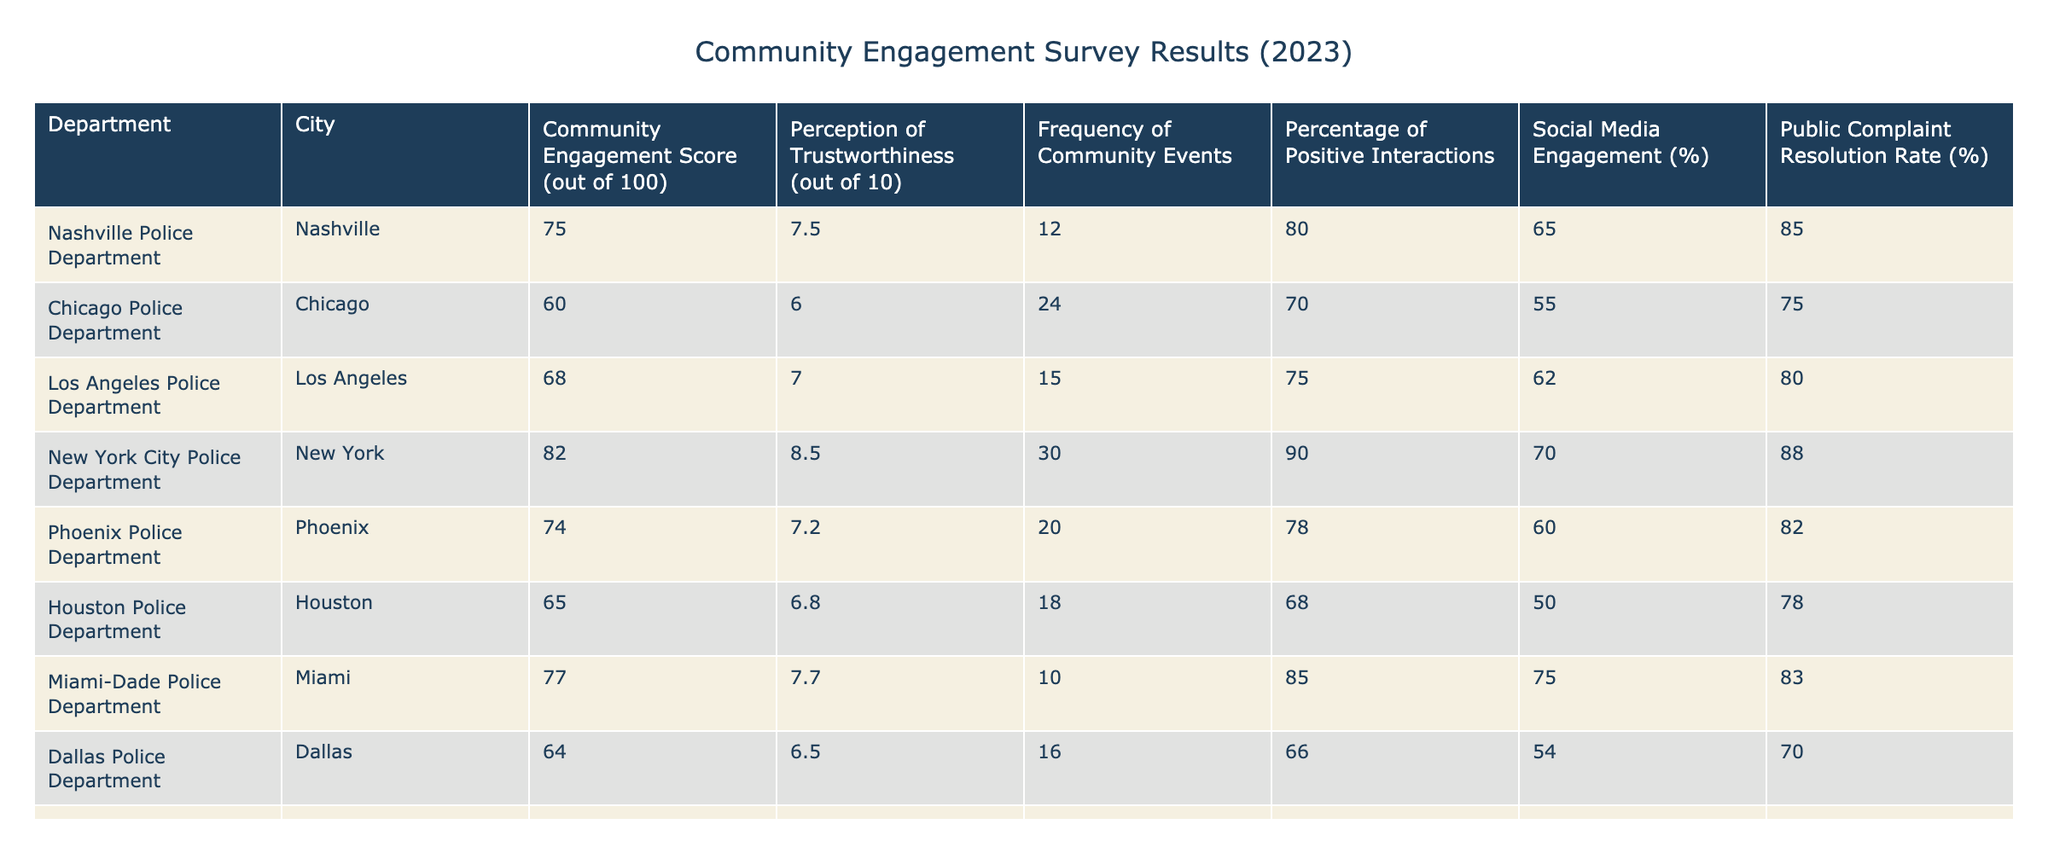What is the Community Engagement Score of the New York City Police Department? The Community Engagement Score can be found in the corresponding row for the New York City Police Department. This department's score is listed as 82.
Answer: 82 Which department has the highest Perception of Trustworthiness? By examining the Perception of Trustworthiness column, we see that the New York City Police Department has a score of 8.5, which is the highest compared to other departments.
Answer: New York City Police Department What is the percentage of positive interactions for the Chicago Police Department? In the row for the Chicago Police Department, the Percentage of Positive Interactions is listed as 70%.
Answer: 70% Calculate the average Community Engagement Score of all departments listed. To find the average, add all the Community Engagement Scores together: 75 + 60 + 68 + 82 + 74 + 65 + 77 + 64 + 80 + 70 = 744. There are 10 departments, so 744 divided by 10 equals 74.4.
Answer: 74.4 Is the Public Complaint Resolution Rate for the Miami-Dade Police Department above 80%? Look at the Public Complaint Resolution Rate for the Miami-Dade Police Department, which is listed as 83%. Since 83% is greater than 80%, the answer is yes.
Answer: Yes Which department has the lowest Social Media Engagement percentage? By checking the Social Media Engagement column, I see the lowest percentage is for the Houston Police Department, which is 50%.
Answer: Houston Police Department How many community events does the Seattle Police Department hold? In the cells for the Seattle Police Department, it lists that they conduct 22 community events.
Answer: 22 What is the difference in Community Engagement Scores between the Nashville Police Department and the Houston Police Department? The Nashville Police Department has a Community Engagement Score of 75, while the Houston Police Department has a score of 65. Subtracting these gives 75 - 65 = 10.
Answer: 10 Does any department have a Perception of Trustworthiness score lower than 7.0? By reviewing the Perception of Trustworthiness column, I notice that both the Chicago Police Department (6.0) and the Dallas Police Department (6.5) have scores under 7.0. Therefore, the answer is yes.
Answer: Yes 